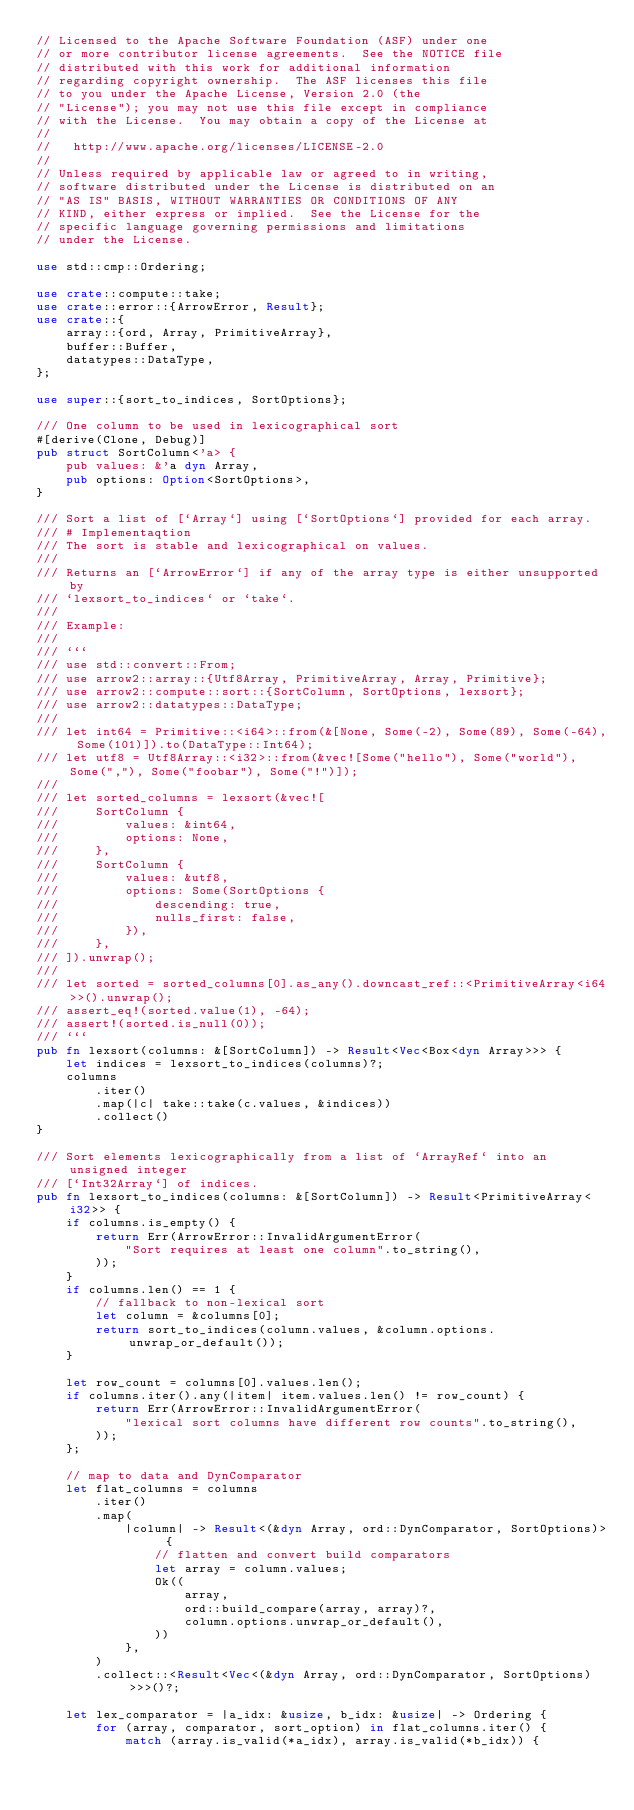<code> <loc_0><loc_0><loc_500><loc_500><_Rust_>// Licensed to the Apache Software Foundation (ASF) under one
// or more contributor license agreements.  See the NOTICE file
// distributed with this work for additional information
// regarding copyright ownership.  The ASF licenses this file
// to you under the Apache License, Version 2.0 (the
// "License"); you may not use this file except in compliance
// with the License.  You may obtain a copy of the License at
//
//   http://www.apache.org/licenses/LICENSE-2.0
//
// Unless required by applicable law or agreed to in writing,
// software distributed under the License is distributed on an
// "AS IS" BASIS, WITHOUT WARRANTIES OR CONDITIONS OF ANY
// KIND, either express or implied.  See the License for the
// specific language governing permissions and limitations
// under the License.

use std::cmp::Ordering;

use crate::compute::take;
use crate::error::{ArrowError, Result};
use crate::{
    array::{ord, Array, PrimitiveArray},
    buffer::Buffer,
    datatypes::DataType,
};

use super::{sort_to_indices, SortOptions};

/// One column to be used in lexicographical sort
#[derive(Clone, Debug)]
pub struct SortColumn<'a> {
    pub values: &'a dyn Array,
    pub options: Option<SortOptions>,
}

/// Sort a list of [`Array`] using [`SortOptions`] provided for each array.
/// # Implementaqtion
/// The sort is stable and lexicographical on values.
///
/// Returns an [`ArrowError`] if any of the array type is either unsupported by
/// `lexsort_to_indices` or `take`.
///
/// Example:
///
/// ```
/// use std::convert::From;
/// use arrow2::array::{Utf8Array, PrimitiveArray, Array, Primitive};
/// use arrow2::compute::sort::{SortColumn, SortOptions, lexsort};
/// use arrow2::datatypes::DataType;
///
/// let int64 = Primitive::<i64>::from(&[None, Some(-2), Some(89), Some(-64), Some(101)]).to(DataType::Int64);
/// let utf8 = Utf8Array::<i32>::from(&vec![Some("hello"), Some("world"), Some(","), Some("foobar"), Some("!")]);
///
/// let sorted_columns = lexsort(&vec![
///     SortColumn {
///         values: &int64,
///         options: None,
///     },
///     SortColumn {
///         values: &utf8,
///         options: Some(SortOptions {
///             descending: true,
///             nulls_first: false,
///         }),
///     },
/// ]).unwrap();
///
/// let sorted = sorted_columns[0].as_any().downcast_ref::<PrimitiveArray<i64>>().unwrap();
/// assert_eq!(sorted.value(1), -64);
/// assert!(sorted.is_null(0));
/// ```
pub fn lexsort(columns: &[SortColumn]) -> Result<Vec<Box<dyn Array>>> {
    let indices = lexsort_to_indices(columns)?;
    columns
        .iter()
        .map(|c| take::take(c.values, &indices))
        .collect()
}

/// Sort elements lexicographically from a list of `ArrayRef` into an unsigned integer
/// [`Int32Array`] of indices.
pub fn lexsort_to_indices(columns: &[SortColumn]) -> Result<PrimitiveArray<i32>> {
    if columns.is_empty() {
        return Err(ArrowError::InvalidArgumentError(
            "Sort requires at least one column".to_string(),
        ));
    }
    if columns.len() == 1 {
        // fallback to non-lexical sort
        let column = &columns[0];
        return sort_to_indices(column.values, &column.options.unwrap_or_default());
    }

    let row_count = columns[0].values.len();
    if columns.iter().any(|item| item.values.len() != row_count) {
        return Err(ArrowError::InvalidArgumentError(
            "lexical sort columns have different row counts".to_string(),
        ));
    };

    // map to data and DynComparator
    let flat_columns = columns
        .iter()
        .map(
            |column| -> Result<(&dyn Array, ord::DynComparator, SortOptions)> {
                // flatten and convert build comparators
                let array = column.values;
                Ok((
                    array,
                    ord::build_compare(array, array)?,
                    column.options.unwrap_or_default(),
                ))
            },
        )
        .collect::<Result<Vec<(&dyn Array, ord::DynComparator, SortOptions)>>>()?;

    let lex_comparator = |a_idx: &usize, b_idx: &usize| -> Ordering {
        for (array, comparator, sort_option) in flat_columns.iter() {
            match (array.is_valid(*a_idx), array.is_valid(*b_idx)) {</code> 